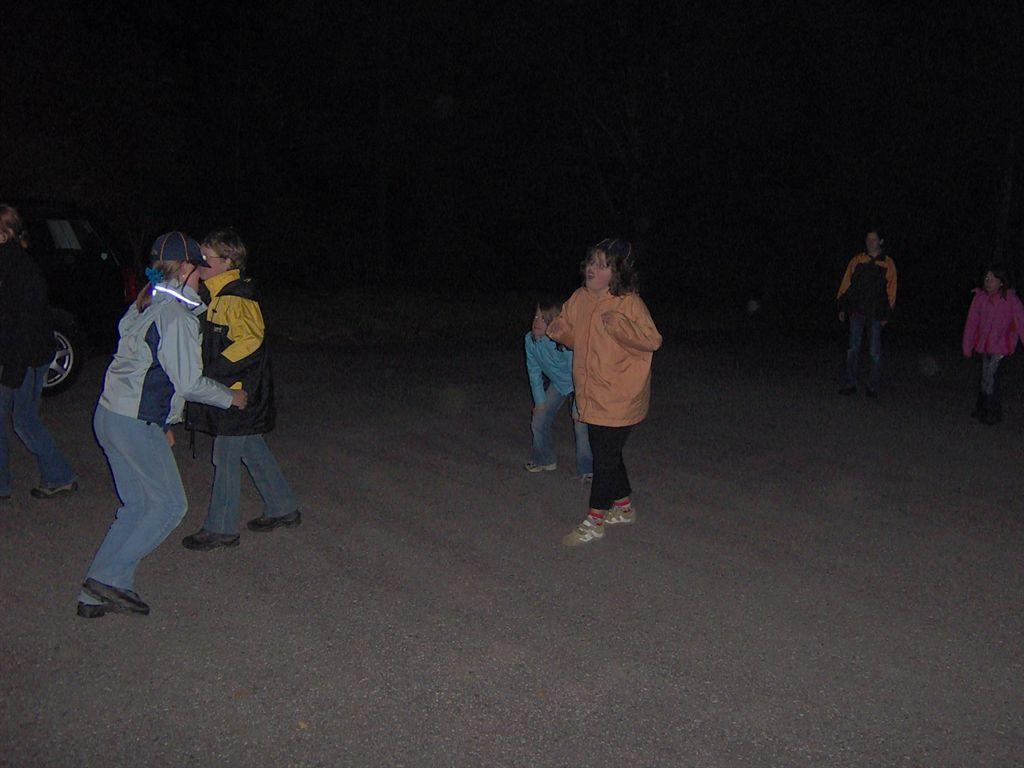What are the people in the image doing? There are people standing and walking in the image. Can you describe the vehicle in the image? There is a car on the left side of the image. What is the color of the background in the image? The background of the image is dark. What flavor of ice cream can be seen in the image? There is no ice cream present in the image. How does the person in the image walk without legs? The image does not depict a person walking without legs; all the people in the image have legs. 